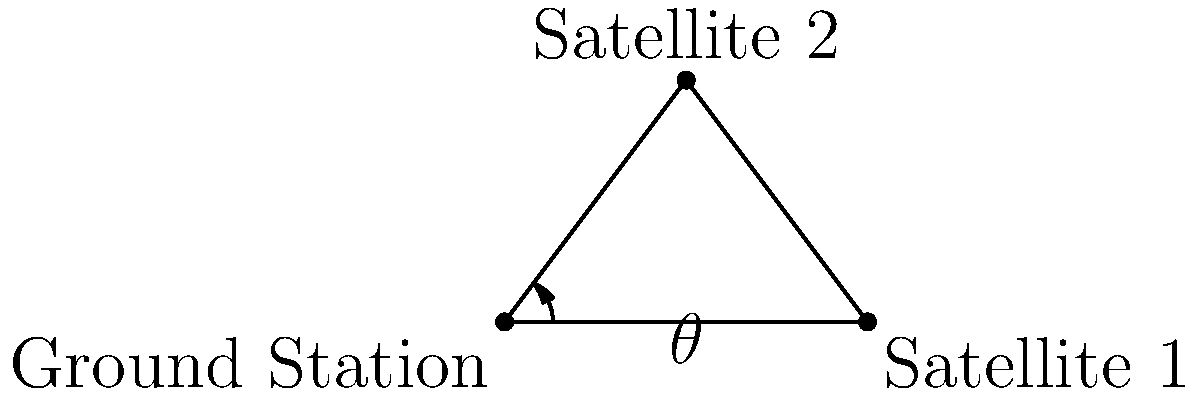Given two communication satellites and a ground station forming a triangle as shown in the diagram, where the distance between the ground station and each satellite is 100,000 km, and the angle $\theta$ between the two satellites as seen from the ground station is 53°, determine the optimal angle $\alpha$ between one satellite and the line connecting the other satellite to the ground station that maximizes the signal strength. Assume the signal strength is proportional to $\cos^2(\alpha)$. To solve this problem, we'll follow these steps:

1) First, we need to recognize that this forms an isosceles triangle, as the distances from the ground station to both satellites are equal.

2) In an isosceles triangle, the base angles are equal. Let's call this base angle $\beta$.

3) We know that the sum of angles in a triangle is 180°. So:

   $$2\beta + 53° = 180°$$

4) Solving for $\beta$:

   $$2\beta = 127°$$
   $$\beta = 63.5°$$

5) The angle we're looking for, $\alpha$, is the complement of $\beta$:

   $$\alpha = 90° - \beta = 90° - 63.5° = 26.5°$$

6) To verify this is indeed the optimal angle, we can consider the signal strength function:

   $$S(\alpha) = \cos^2(\alpha)$$

7) The maximum of this function occurs when $\alpha = 0°$ (directly facing the satellite), and decreases as $\alpha$ increases up to 90°.

8) Given the constraints of our triangle, 26.5° is the smallest possible angle between a satellite and the line connecting the other satellite to the ground station, thus maximizing the signal strength.
Answer: 26.5° 